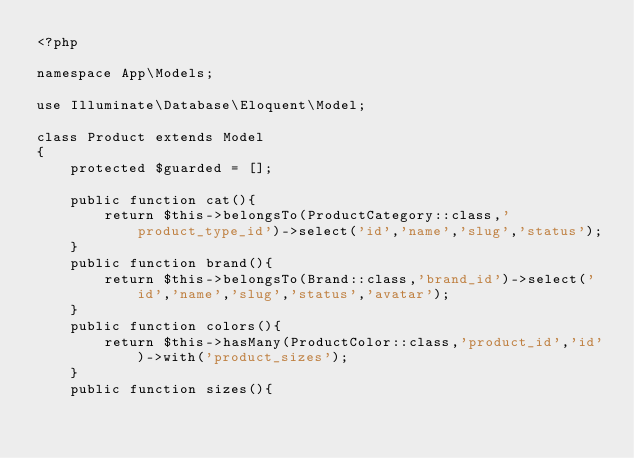Convert code to text. <code><loc_0><loc_0><loc_500><loc_500><_PHP_><?php

namespace App\Models;

use Illuminate\Database\Eloquent\Model;

class Product extends Model
{
    protected $guarded = [];

    public function cat(){
        return $this->belongsTo(ProductCategory::class,'product_type_id')->select('id','name','slug','status');
    }
    public function brand(){
        return $this->belongsTo(Brand::class,'brand_id')->select('id','name','slug','status','avatar');
    }
    public function colors(){
        return $this->hasMany(ProductColor::class,'product_id','id')->with('product_sizes');
    }
    public function sizes(){</code> 